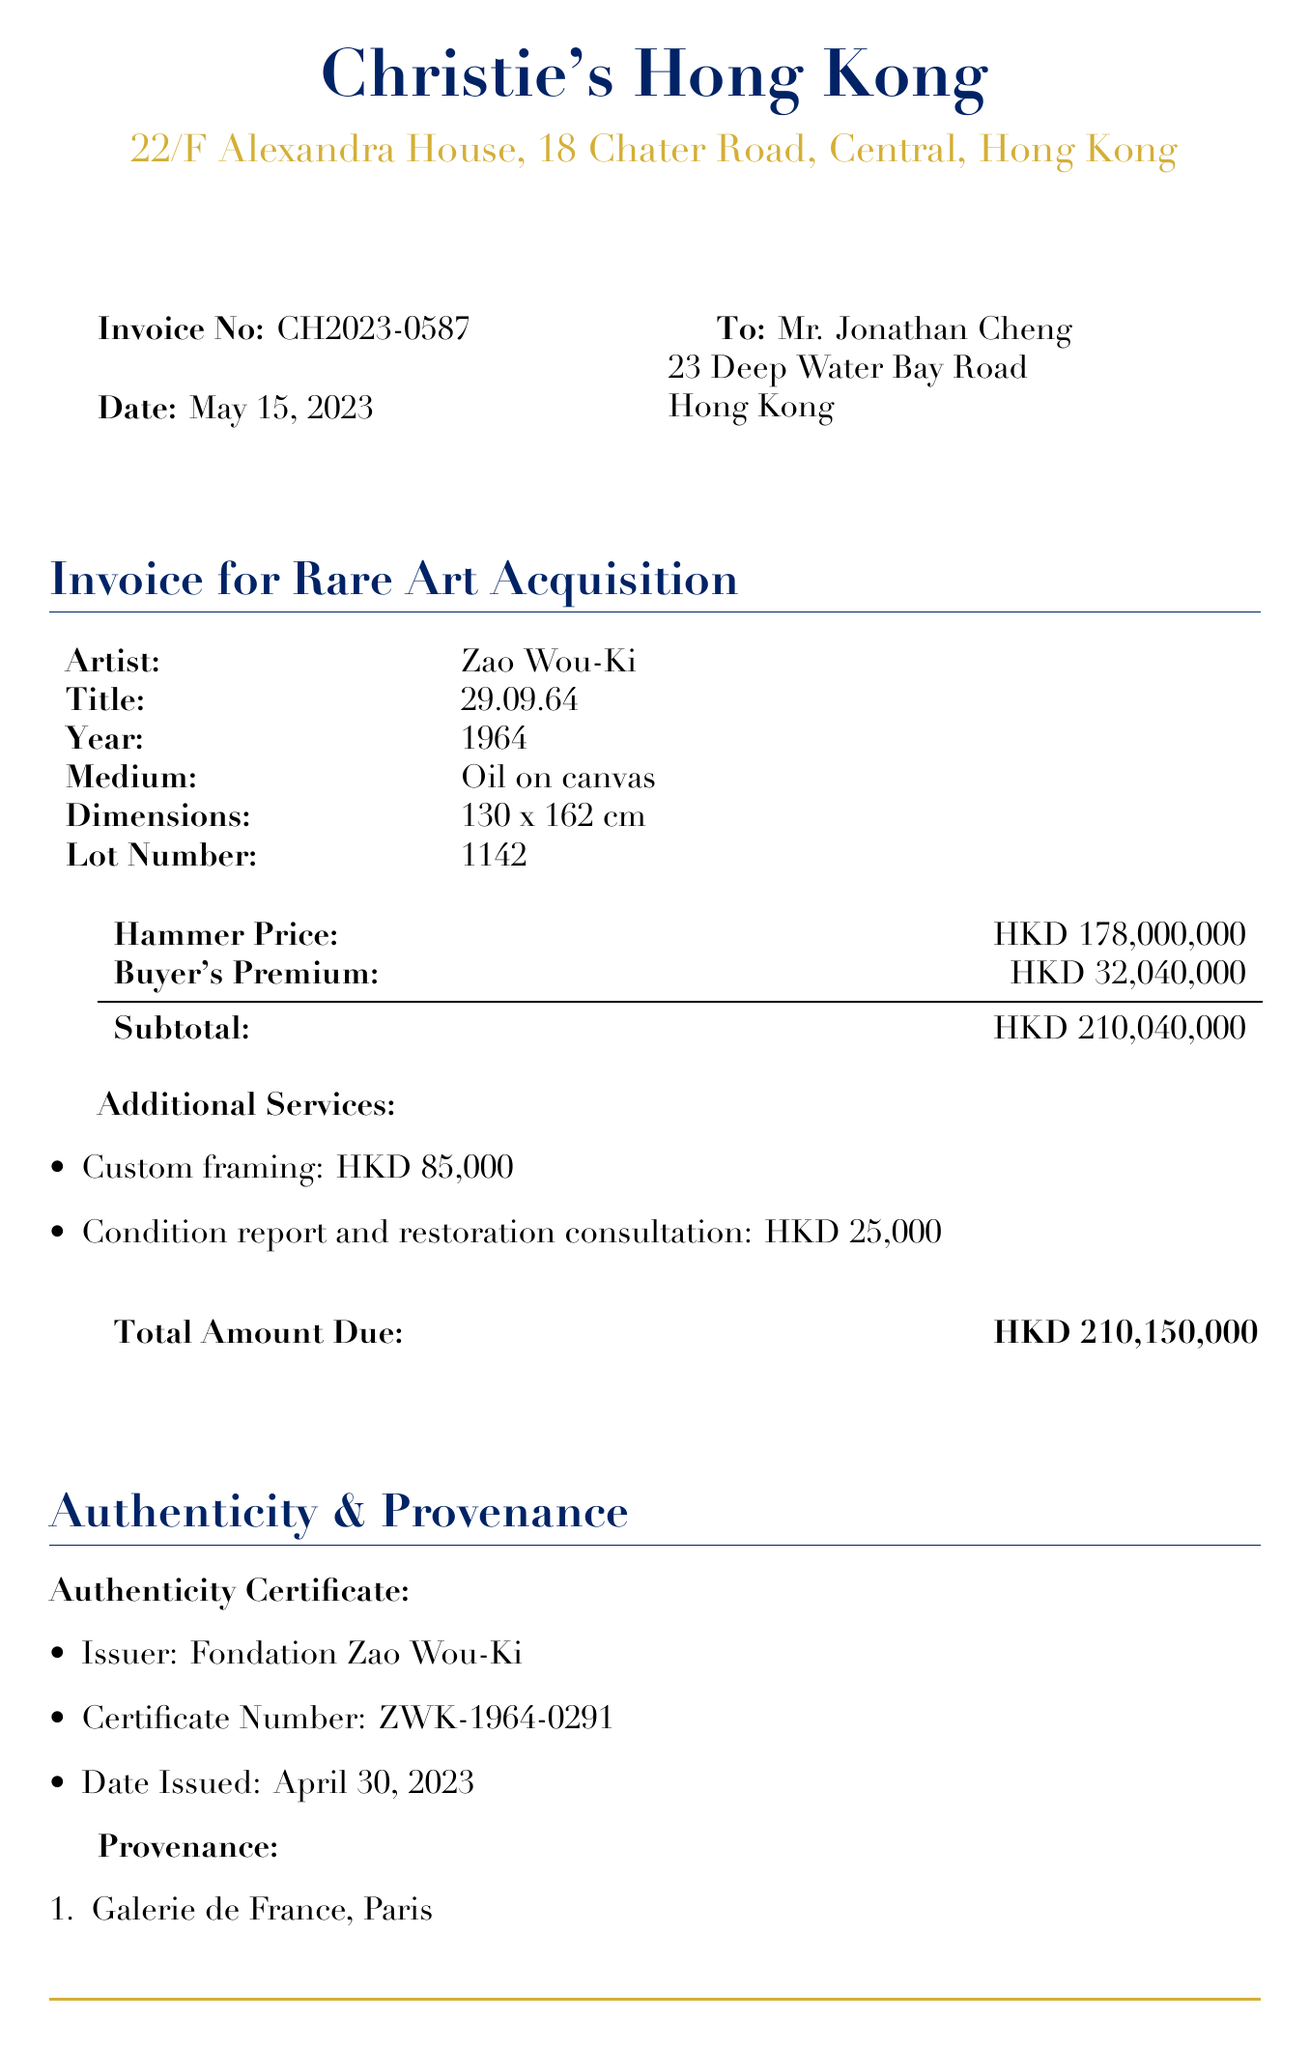What is the invoice number? The invoice number can be found in the document as a unique identifier for this transaction.
Answer: CH2023-0587 Who is the artist of the artwork? The artist is listed in the artwork details section of the document.
Answer: Zao Wou-Ki What is the total price for the acquisition? The total price is summarized in the financial details of the document.
Answer: HKD 210,040,000 When was the authenticity certificate issued? The date of issue for the authenticity certificate can be found under the authenticity section.
Answer: April 30, 2023 What is the method of shipping? The shipping method is detailed in the shipping section of the invoice.
Answer: Fine Art Logistics Hong Kong Ltd What is the due date for payment? The document specifies the due date for payment under payment terms.
Answer: May 29, 2023 How much is the custom framing service? The additional services section lists the price for custom framing.
Answer: HKD 85,000 Where was the artwork acquired prior to this auction? The provenance section provides a list of previous owners of the artwork.
Answer: Private Collection, Asia What is included in the insurance for shipping? The document describes the insurance coverage included with the shipping.
Answer: full value coverage 